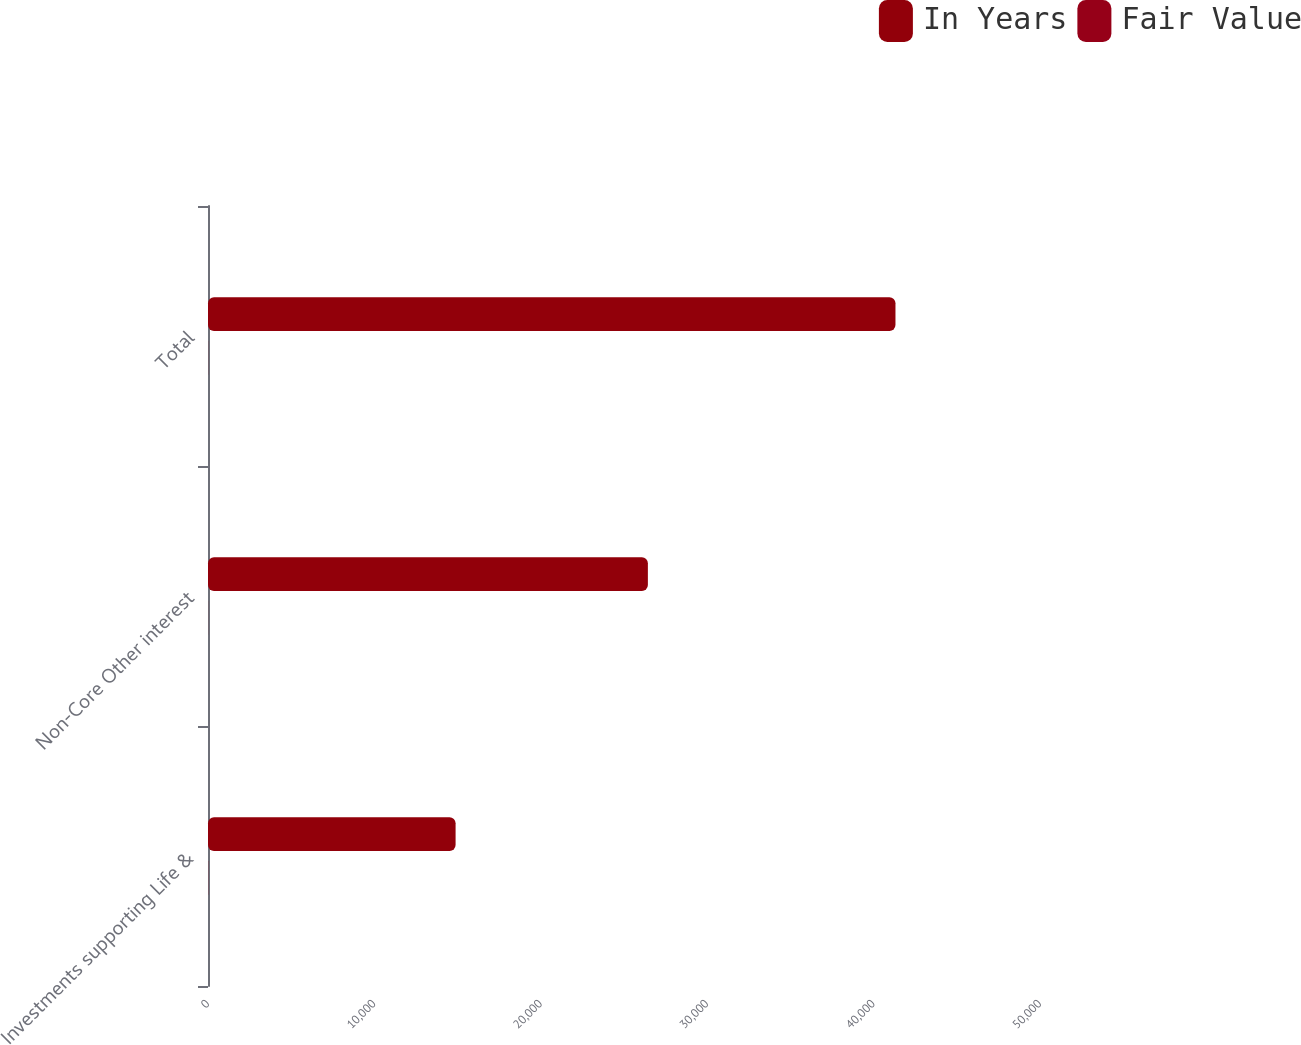Convert chart to OTSL. <chart><loc_0><loc_0><loc_500><loc_500><stacked_bar_chart><ecel><fcel>Investments supporting Life &<fcel>Non-Core Other interest<fcel>Total<nl><fcel>In Years<fcel>14879<fcel>26435<fcel>41314<nl><fcel>Fair Value<fcel>9.6<fcel>4.3<fcel>6.2<nl></chart> 